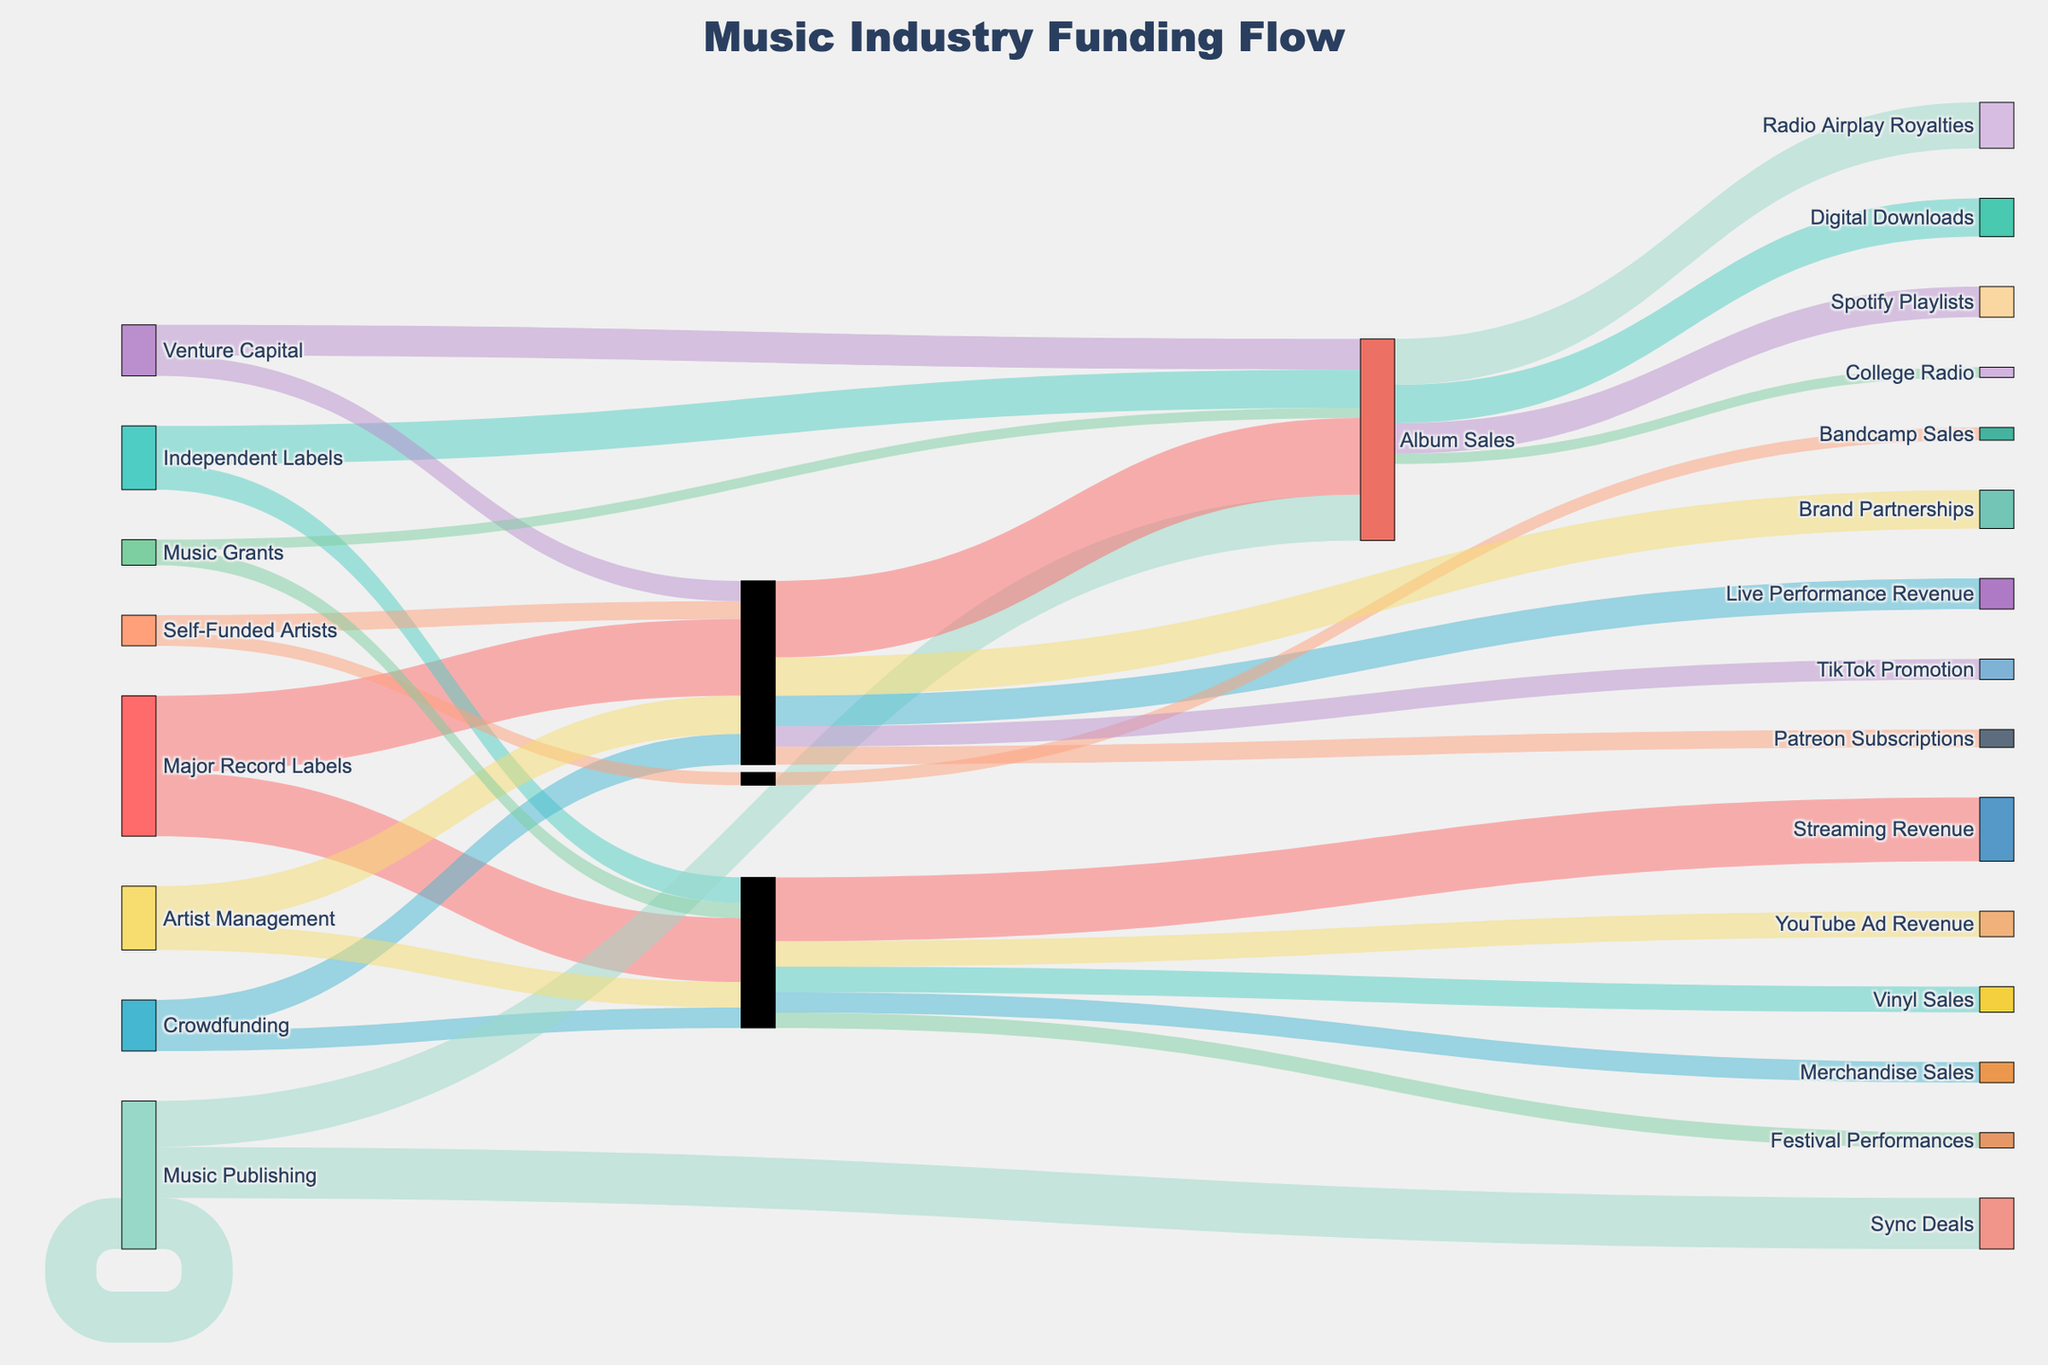What are the main funding sources shown in the Sankey Diagram? Identify the different nodes designated as "Source" in the Sankey Diagram. The main funding sources are "Major Record Labels", "Independent Labels", "Crowdfunding", "Self-Funded Artists", "Music Publishing", "Artist Management", "Venture Capital", and "Music Grants".
Answer: Major Record Labels, Independent Labels, Crowdfunding, Self-Funded Artists, Music Publishing, Artist Management, Venture Capital, Music Grants What is the primary target of funding from Major Record Labels? Track the flows originating from "Major Record Labels" and look for the largest value. The largest value is 'Album Sales' with 30 units.
Answer: Album Sales Which target receives funding from both Crowdfunding and Major Record Labels? Observe the targets that have connections from both "Crowdfunding" and "Major Record Labels". "Merchandise Sales" receives funding from Crowdfunding but not Major Record Labels; none of the targets matches the criteria thoroughly.
Answer: None How much funding goes into marketing from all sources combined? Sum up all the values directed towards the "Marketing" intermediate node. The values are 30 (Major Record Labels) + 12 (Crowdfunding) + 7 (Self-Funded Artists) + 15 (Artist Management) + 8 (Venture Capital) = 72.
Answer: 72 What is the combined funding received by "Digital Downloads", "Vinyl Sales", and "Spotify Playlists"? Sum the funds transferred to each of these targets: 15 (Digital Downloads) + 10 (Vinyl Sales) + 12 (Spotify Playlists) = 37.
Answer: 37 How does the funding for "Live Performance Revenue" from Crowdfunding compare to funding for "Festival Performances" from Music Grants? Compare funding values: "Live Performance Revenue" from Crowdfunding is 12, whereas "Festival Performances" from Music Grants is 6. Therefore, "Live Performance Revenue" funding is greater.
Answer: Live Performance Revenue (Crowdfunding) How is the funding into "Sync Deals" from Music Publishing different from funding into "TikTok Promotion" from Venture Capital? Compare the target values: "Sync Deals" has funding of 20, while "TikTok Promotion" receives 8. The funding for Sync Deals is significantly higher.
Answer: Sync Deals (20) - TikTok Promotion (8) = 12 Which funding source directs the most funds towards "Production"? Identify the funding sources and their allocations to "Production". Major Record Labels provide 25 units, which is the highest allocation to Production.
Answer: Major Record Labels Which target receives the least amount of funding? Observe the target nodes and their values. "College Radio" receives the least funding with 4 units.
Answer: College Radio 